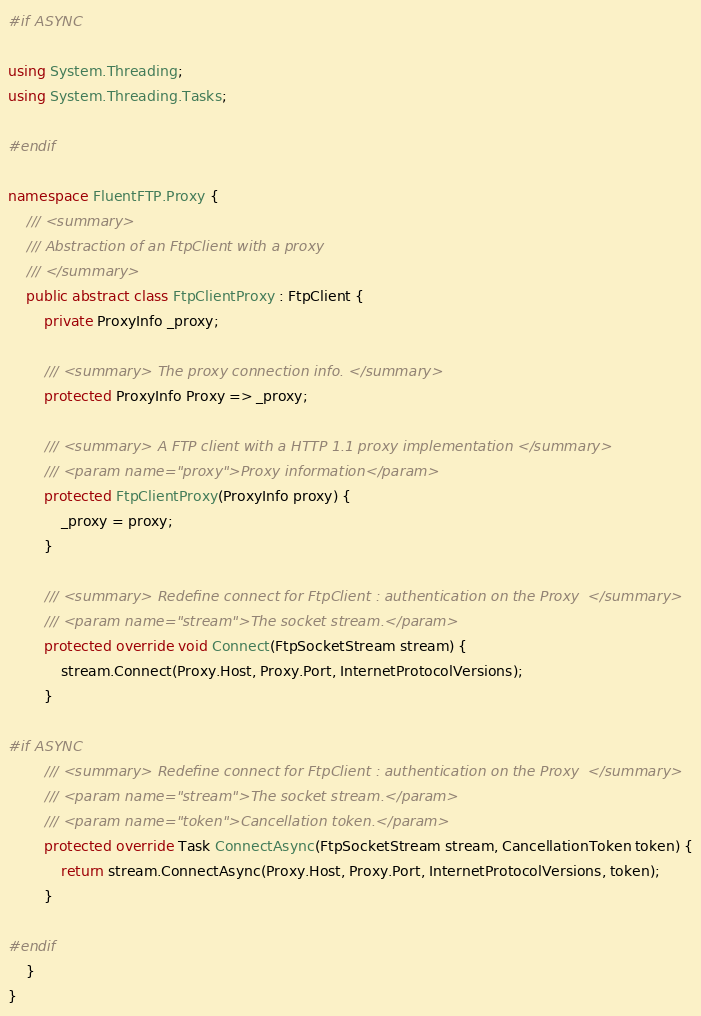<code> <loc_0><loc_0><loc_500><loc_500><_C#_>#if ASYNC

using System.Threading;
using System.Threading.Tasks;

#endif

namespace FluentFTP.Proxy {
	/// <summary>
	/// Abstraction of an FtpClient with a proxy
	/// </summary>
	public abstract class FtpClientProxy : FtpClient {
		private ProxyInfo _proxy;

		/// <summary> The proxy connection info. </summary>
		protected ProxyInfo Proxy => _proxy;

		/// <summary> A FTP client with a HTTP 1.1 proxy implementation </summary>
		/// <param name="proxy">Proxy information</param>
		protected FtpClientProxy(ProxyInfo proxy) {
			_proxy = proxy;
		}

		/// <summary> Redefine connect for FtpClient : authentication on the Proxy  </summary>
		/// <param name="stream">The socket stream.</param>
		protected override void Connect(FtpSocketStream stream) {
			stream.Connect(Proxy.Host, Proxy.Port, InternetProtocolVersions);
		}

#if ASYNC
		/// <summary> Redefine connect for FtpClient : authentication on the Proxy  </summary>
		/// <param name="stream">The socket stream.</param>
		/// <param name="token">Cancellation token.</param>
		protected override Task ConnectAsync(FtpSocketStream stream, CancellationToken token) {
			return stream.ConnectAsync(Proxy.Host, Proxy.Port, InternetProtocolVersions, token);
		}

#endif
	}
}</code> 